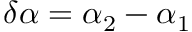<formula> <loc_0><loc_0><loc_500><loc_500>\delta \alpha = \alpha _ { 2 } - \alpha _ { 1 }</formula> 